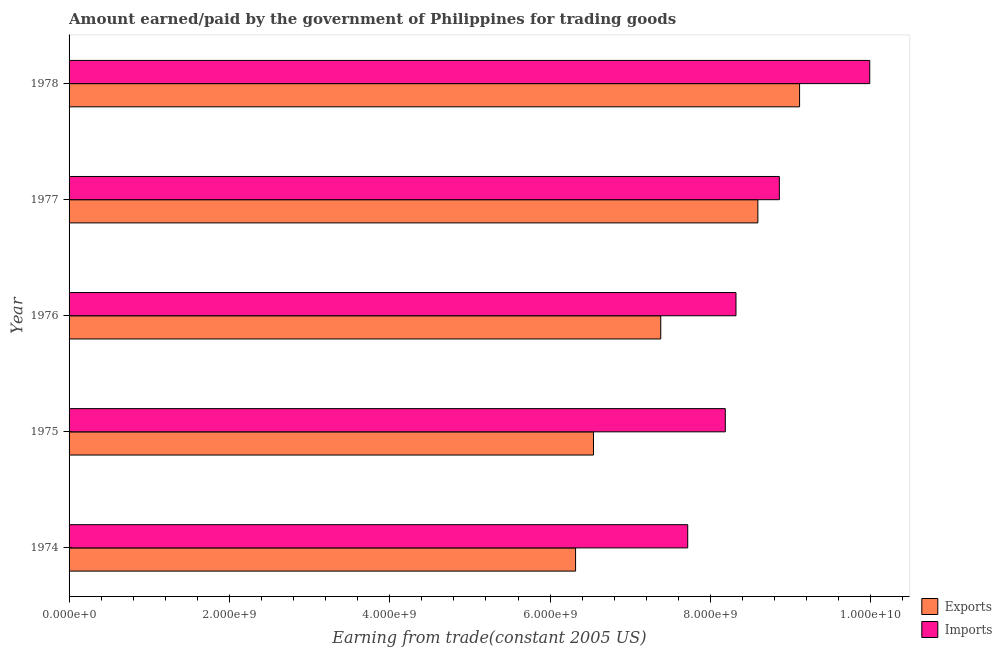What is the label of the 5th group of bars from the top?
Make the answer very short. 1974. What is the amount paid for imports in 1977?
Your answer should be compact. 8.86e+09. Across all years, what is the maximum amount earned from exports?
Ensure brevity in your answer.  9.11e+09. Across all years, what is the minimum amount paid for imports?
Offer a very short reply. 7.72e+09. In which year was the amount earned from exports maximum?
Your response must be concise. 1978. In which year was the amount paid for imports minimum?
Offer a very short reply. 1974. What is the total amount paid for imports in the graph?
Provide a short and direct response. 4.31e+1. What is the difference between the amount paid for imports in 1974 and that in 1975?
Provide a succinct answer. -4.69e+08. What is the difference between the amount earned from exports in 1977 and the amount paid for imports in 1978?
Make the answer very short. -1.40e+09. What is the average amount paid for imports per year?
Offer a terse response. 8.61e+09. In the year 1977, what is the difference between the amount earned from exports and amount paid for imports?
Offer a terse response. -2.68e+08. What is the ratio of the amount earned from exports in 1975 to that in 1977?
Offer a very short reply. 0.76. What is the difference between the highest and the second highest amount paid for imports?
Provide a succinct answer. 1.13e+09. What is the difference between the highest and the lowest amount paid for imports?
Give a very brief answer. 2.27e+09. What does the 2nd bar from the top in 1977 represents?
Provide a short and direct response. Exports. What does the 2nd bar from the bottom in 1975 represents?
Provide a short and direct response. Imports. How many years are there in the graph?
Ensure brevity in your answer.  5. What is the difference between two consecutive major ticks on the X-axis?
Offer a terse response. 2.00e+09. How many legend labels are there?
Make the answer very short. 2. What is the title of the graph?
Your answer should be very brief. Amount earned/paid by the government of Philippines for trading goods. Does "Formally registered" appear as one of the legend labels in the graph?
Offer a very short reply. No. What is the label or title of the X-axis?
Keep it short and to the point. Earning from trade(constant 2005 US). What is the label or title of the Y-axis?
Keep it short and to the point. Year. What is the Earning from trade(constant 2005 US) in Exports in 1974?
Provide a succinct answer. 6.32e+09. What is the Earning from trade(constant 2005 US) of Imports in 1974?
Offer a terse response. 7.72e+09. What is the Earning from trade(constant 2005 US) in Exports in 1975?
Give a very brief answer. 6.54e+09. What is the Earning from trade(constant 2005 US) in Imports in 1975?
Offer a terse response. 8.19e+09. What is the Earning from trade(constant 2005 US) of Exports in 1976?
Your answer should be very brief. 7.38e+09. What is the Earning from trade(constant 2005 US) of Imports in 1976?
Ensure brevity in your answer.  8.32e+09. What is the Earning from trade(constant 2005 US) of Exports in 1977?
Ensure brevity in your answer.  8.59e+09. What is the Earning from trade(constant 2005 US) of Imports in 1977?
Provide a succinct answer. 8.86e+09. What is the Earning from trade(constant 2005 US) of Exports in 1978?
Offer a very short reply. 9.11e+09. What is the Earning from trade(constant 2005 US) of Imports in 1978?
Give a very brief answer. 9.99e+09. Across all years, what is the maximum Earning from trade(constant 2005 US) of Exports?
Offer a terse response. 9.11e+09. Across all years, what is the maximum Earning from trade(constant 2005 US) in Imports?
Offer a very short reply. 9.99e+09. Across all years, what is the minimum Earning from trade(constant 2005 US) of Exports?
Keep it short and to the point. 6.32e+09. Across all years, what is the minimum Earning from trade(constant 2005 US) in Imports?
Offer a very short reply. 7.72e+09. What is the total Earning from trade(constant 2005 US) of Exports in the graph?
Your answer should be very brief. 3.79e+1. What is the total Earning from trade(constant 2005 US) of Imports in the graph?
Your answer should be very brief. 4.31e+1. What is the difference between the Earning from trade(constant 2005 US) of Exports in 1974 and that in 1975?
Keep it short and to the point. -2.23e+08. What is the difference between the Earning from trade(constant 2005 US) in Imports in 1974 and that in 1975?
Keep it short and to the point. -4.69e+08. What is the difference between the Earning from trade(constant 2005 US) in Exports in 1974 and that in 1976?
Offer a terse response. -1.06e+09. What is the difference between the Earning from trade(constant 2005 US) of Imports in 1974 and that in 1976?
Keep it short and to the point. -6.02e+08. What is the difference between the Earning from trade(constant 2005 US) in Exports in 1974 and that in 1977?
Offer a very short reply. -2.27e+09. What is the difference between the Earning from trade(constant 2005 US) in Imports in 1974 and that in 1977?
Provide a short and direct response. -1.14e+09. What is the difference between the Earning from trade(constant 2005 US) of Exports in 1974 and that in 1978?
Your answer should be compact. -2.79e+09. What is the difference between the Earning from trade(constant 2005 US) of Imports in 1974 and that in 1978?
Your response must be concise. -2.27e+09. What is the difference between the Earning from trade(constant 2005 US) of Exports in 1975 and that in 1976?
Your answer should be very brief. -8.39e+08. What is the difference between the Earning from trade(constant 2005 US) of Imports in 1975 and that in 1976?
Keep it short and to the point. -1.33e+08. What is the difference between the Earning from trade(constant 2005 US) of Exports in 1975 and that in 1977?
Give a very brief answer. -2.05e+09. What is the difference between the Earning from trade(constant 2005 US) in Imports in 1975 and that in 1977?
Ensure brevity in your answer.  -6.74e+08. What is the difference between the Earning from trade(constant 2005 US) of Exports in 1975 and that in 1978?
Ensure brevity in your answer.  -2.57e+09. What is the difference between the Earning from trade(constant 2005 US) in Imports in 1975 and that in 1978?
Your answer should be compact. -1.80e+09. What is the difference between the Earning from trade(constant 2005 US) in Exports in 1976 and that in 1977?
Offer a terse response. -1.21e+09. What is the difference between the Earning from trade(constant 2005 US) in Imports in 1976 and that in 1977?
Offer a very short reply. -5.41e+08. What is the difference between the Earning from trade(constant 2005 US) in Exports in 1976 and that in 1978?
Your answer should be very brief. -1.73e+09. What is the difference between the Earning from trade(constant 2005 US) in Imports in 1976 and that in 1978?
Give a very brief answer. -1.67e+09. What is the difference between the Earning from trade(constant 2005 US) in Exports in 1977 and that in 1978?
Your answer should be very brief. -5.20e+08. What is the difference between the Earning from trade(constant 2005 US) of Imports in 1977 and that in 1978?
Provide a short and direct response. -1.13e+09. What is the difference between the Earning from trade(constant 2005 US) in Exports in 1974 and the Earning from trade(constant 2005 US) in Imports in 1975?
Ensure brevity in your answer.  -1.87e+09. What is the difference between the Earning from trade(constant 2005 US) in Exports in 1974 and the Earning from trade(constant 2005 US) in Imports in 1976?
Offer a terse response. -2.00e+09. What is the difference between the Earning from trade(constant 2005 US) of Exports in 1974 and the Earning from trade(constant 2005 US) of Imports in 1977?
Offer a very short reply. -2.54e+09. What is the difference between the Earning from trade(constant 2005 US) in Exports in 1974 and the Earning from trade(constant 2005 US) in Imports in 1978?
Give a very brief answer. -3.67e+09. What is the difference between the Earning from trade(constant 2005 US) in Exports in 1975 and the Earning from trade(constant 2005 US) in Imports in 1976?
Give a very brief answer. -1.78e+09. What is the difference between the Earning from trade(constant 2005 US) in Exports in 1975 and the Earning from trade(constant 2005 US) in Imports in 1977?
Keep it short and to the point. -2.32e+09. What is the difference between the Earning from trade(constant 2005 US) in Exports in 1975 and the Earning from trade(constant 2005 US) in Imports in 1978?
Make the answer very short. -3.45e+09. What is the difference between the Earning from trade(constant 2005 US) in Exports in 1976 and the Earning from trade(constant 2005 US) in Imports in 1977?
Give a very brief answer. -1.48e+09. What is the difference between the Earning from trade(constant 2005 US) of Exports in 1976 and the Earning from trade(constant 2005 US) of Imports in 1978?
Provide a short and direct response. -2.61e+09. What is the difference between the Earning from trade(constant 2005 US) in Exports in 1977 and the Earning from trade(constant 2005 US) in Imports in 1978?
Your answer should be compact. -1.40e+09. What is the average Earning from trade(constant 2005 US) of Exports per year?
Your answer should be compact. 7.59e+09. What is the average Earning from trade(constant 2005 US) in Imports per year?
Keep it short and to the point. 8.61e+09. In the year 1974, what is the difference between the Earning from trade(constant 2005 US) of Exports and Earning from trade(constant 2005 US) of Imports?
Keep it short and to the point. -1.40e+09. In the year 1975, what is the difference between the Earning from trade(constant 2005 US) of Exports and Earning from trade(constant 2005 US) of Imports?
Provide a short and direct response. -1.64e+09. In the year 1976, what is the difference between the Earning from trade(constant 2005 US) in Exports and Earning from trade(constant 2005 US) in Imports?
Provide a succinct answer. -9.38e+08. In the year 1977, what is the difference between the Earning from trade(constant 2005 US) of Exports and Earning from trade(constant 2005 US) of Imports?
Ensure brevity in your answer.  -2.68e+08. In the year 1978, what is the difference between the Earning from trade(constant 2005 US) of Exports and Earning from trade(constant 2005 US) of Imports?
Your answer should be compact. -8.75e+08. What is the ratio of the Earning from trade(constant 2005 US) in Exports in 1974 to that in 1975?
Make the answer very short. 0.97. What is the ratio of the Earning from trade(constant 2005 US) of Imports in 1974 to that in 1975?
Keep it short and to the point. 0.94. What is the ratio of the Earning from trade(constant 2005 US) in Exports in 1974 to that in 1976?
Offer a terse response. 0.86. What is the ratio of the Earning from trade(constant 2005 US) in Imports in 1974 to that in 1976?
Make the answer very short. 0.93. What is the ratio of the Earning from trade(constant 2005 US) of Exports in 1974 to that in 1977?
Offer a very short reply. 0.74. What is the ratio of the Earning from trade(constant 2005 US) in Imports in 1974 to that in 1977?
Ensure brevity in your answer.  0.87. What is the ratio of the Earning from trade(constant 2005 US) in Exports in 1974 to that in 1978?
Give a very brief answer. 0.69. What is the ratio of the Earning from trade(constant 2005 US) of Imports in 1974 to that in 1978?
Ensure brevity in your answer.  0.77. What is the ratio of the Earning from trade(constant 2005 US) of Exports in 1975 to that in 1976?
Give a very brief answer. 0.89. What is the ratio of the Earning from trade(constant 2005 US) in Imports in 1975 to that in 1976?
Make the answer very short. 0.98. What is the ratio of the Earning from trade(constant 2005 US) of Exports in 1975 to that in 1977?
Make the answer very short. 0.76. What is the ratio of the Earning from trade(constant 2005 US) of Imports in 1975 to that in 1977?
Make the answer very short. 0.92. What is the ratio of the Earning from trade(constant 2005 US) in Exports in 1975 to that in 1978?
Provide a short and direct response. 0.72. What is the ratio of the Earning from trade(constant 2005 US) of Imports in 1975 to that in 1978?
Provide a succinct answer. 0.82. What is the ratio of the Earning from trade(constant 2005 US) in Exports in 1976 to that in 1977?
Your answer should be compact. 0.86. What is the ratio of the Earning from trade(constant 2005 US) of Imports in 1976 to that in 1977?
Keep it short and to the point. 0.94. What is the ratio of the Earning from trade(constant 2005 US) of Exports in 1976 to that in 1978?
Offer a very short reply. 0.81. What is the ratio of the Earning from trade(constant 2005 US) of Imports in 1976 to that in 1978?
Make the answer very short. 0.83. What is the ratio of the Earning from trade(constant 2005 US) of Exports in 1977 to that in 1978?
Provide a succinct answer. 0.94. What is the ratio of the Earning from trade(constant 2005 US) of Imports in 1977 to that in 1978?
Provide a succinct answer. 0.89. What is the difference between the highest and the second highest Earning from trade(constant 2005 US) of Exports?
Ensure brevity in your answer.  5.20e+08. What is the difference between the highest and the second highest Earning from trade(constant 2005 US) of Imports?
Give a very brief answer. 1.13e+09. What is the difference between the highest and the lowest Earning from trade(constant 2005 US) in Exports?
Provide a short and direct response. 2.79e+09. What is the difference between the highest and the lowest Earning from trade(constant 2005 US) of Imports?
Offer a terse response. 2.27e+09. 